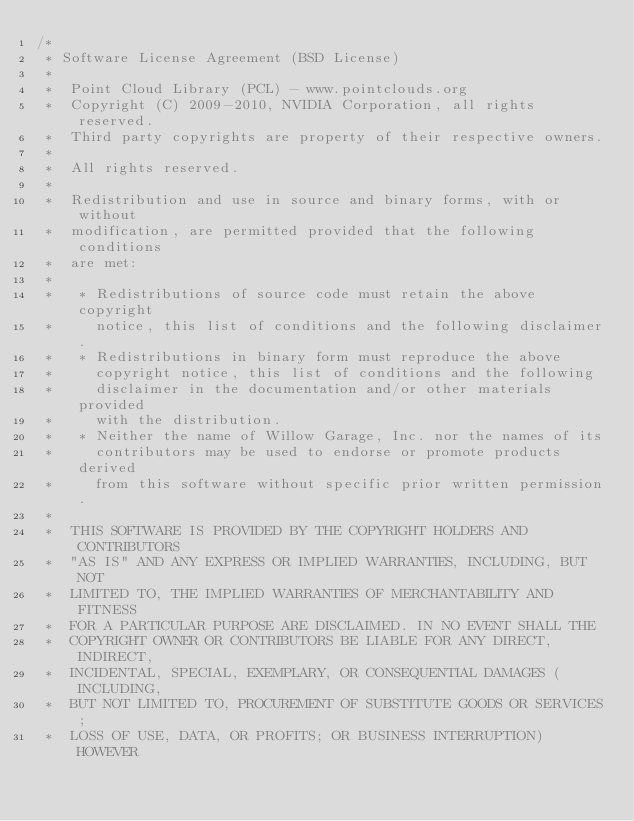Convert code to text. <code><loc_0><loc_0><loc_500><loc_500><_Cuda_>/*
 * Software License Agreement (BSD License)
 *
 *  Point Cloud Library (PCL) - www.pointclouds.org
 *  Copyright (C) 2009-2010, NVIDIA Corporation, all rights reserved.
 *  Third party copyrights are property of their respective owners.
 *
 *  All rights reserved.
 *
 *  Redistribution and use in source and binary forms, with or without
 *  modification, are permitted provided that the following conditions
 *  are met:
 *
 *   * Redistributions of source code must retain the above copyright
 *     notice, this list of conditions and the following disclaimer.
 *   * Redistributions in binary form must reproduce the above
 *     copyright notice, this list of conditions and the following
 *     disclaimer in the documentation and/or other materials provided
 *     with the distribution.
 *   * Neither the name of Willow Garage, Inc. nor the names of its
 *     contributors may be used to endorse or promote products derived
 *     from this software without specific prior written permission.
 *
 *  THIS SOFTWARE IS PROVIDED BY THE COPYRIGHT HOLDERS AND CONTRIBUTORS
 *  "AS IS" AND ANY EXPRESS OR IMPLIED WARRANTIES, INCLUDING, BUT NOT
 *  LIMITED TO, THE IMPLIED WARRANTIES OF MERCHANTABILITY AND FITNESS
 *  FOR A PARTICULAR PURPOSE ARE DISCLAIMED. IN NO EVENT SHALL THE
 *  COPYRIGHT OWNER OR CONTRIBUTORS BE LIABLE FOR ANY DIRECT, INDIRECT,
 *  INCIDENTAL, SPECIAL, EXEMPLARY, OR CONSEQUENTIAL DAMAGES (INCLUDING,
 *  BUT NOT LIMITED TO, PROCUREMENT OF SUBSTITUTE GOODS OR SERVICES;
 *  LOSS OF USE, DATA, OR PROFITS; OR BUSINESS INTERRUPTION) HOWEVER</code> 